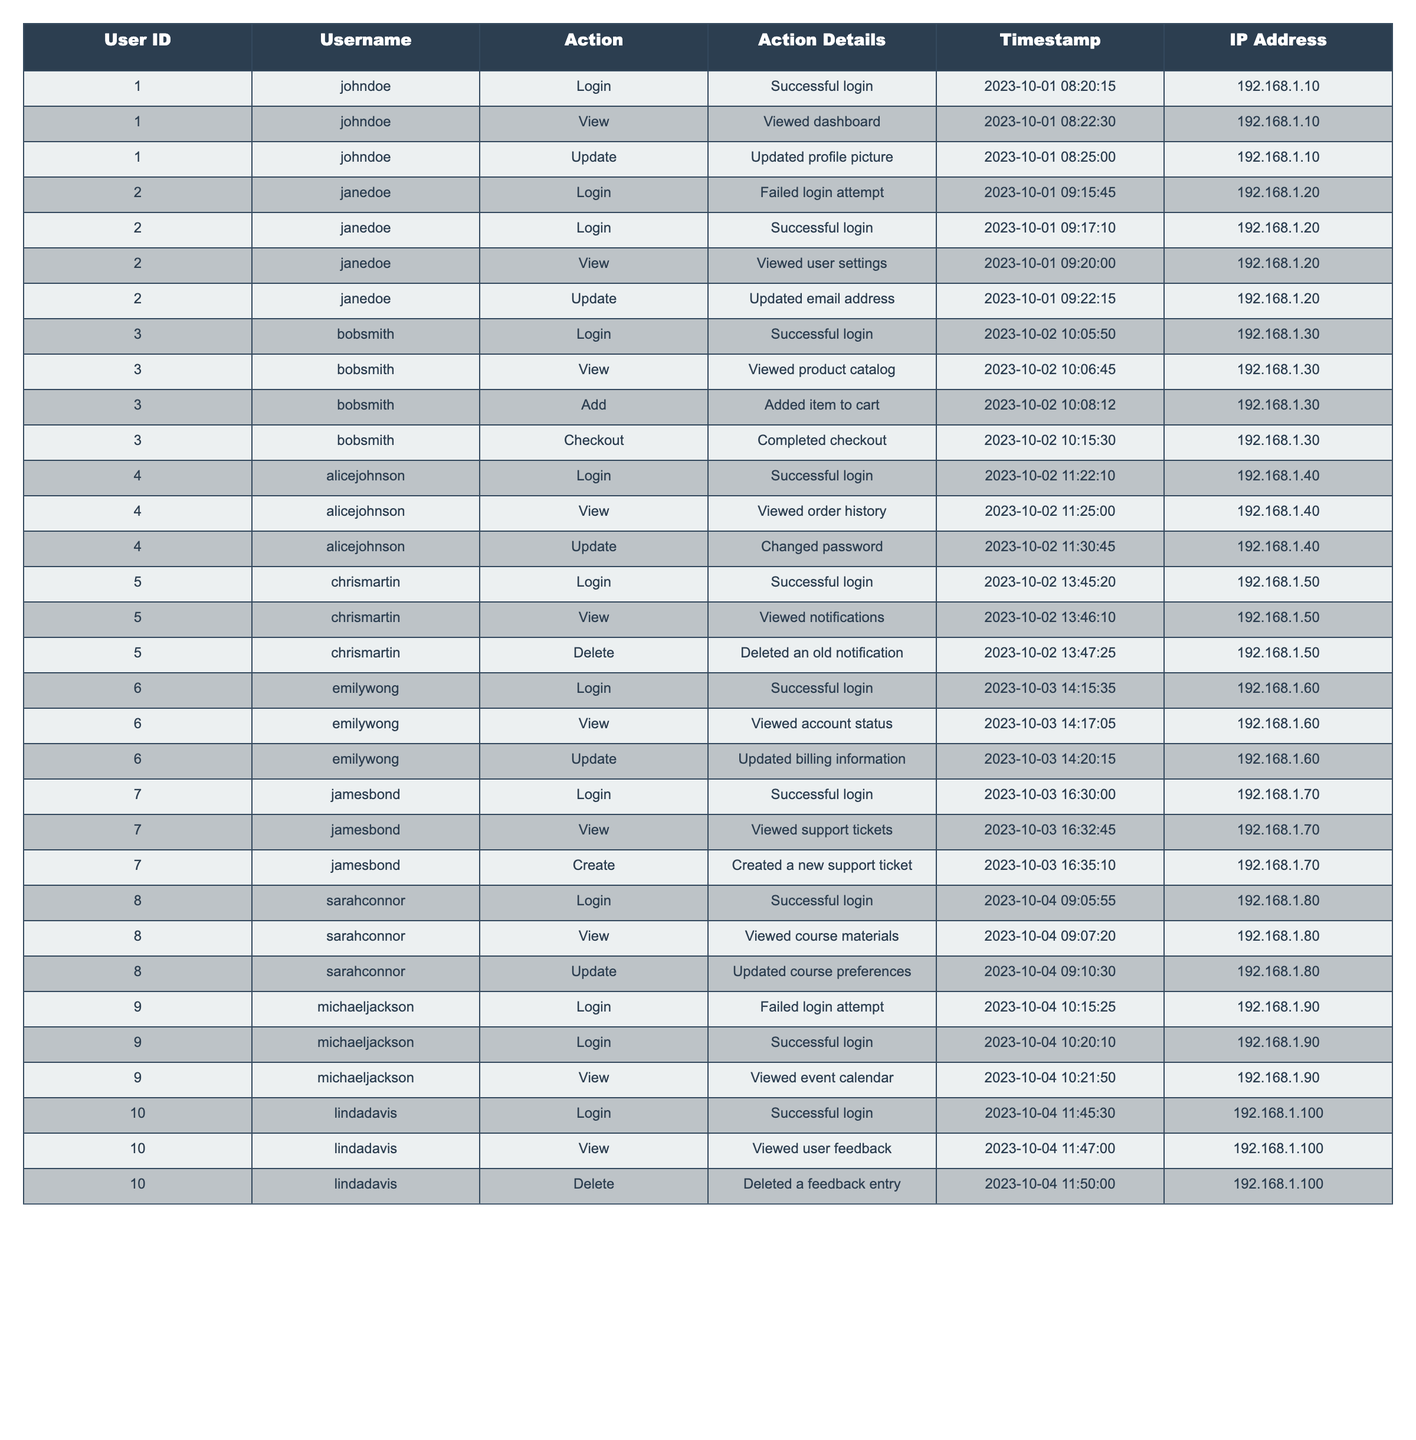What is the most recent action performed by user 'janedoe'? The table lists actions performed by each user along with timestamps. For 'janedoe', the most recent action is 'Updated email address' which occurred on '2023-10-01 09:22:15'.
Answer: Updated email address How many users have successfully logged in more than once? We can look through the logs for successful login actions. Users 'johndoe', 'janedoe', and 'michaeljackson' have logged in more than once, totaling three users.
Answer: 3 Did 'bobsmith' perform any add actions on the logged date? Looking at 'bobsmith's actions, he performed an 'Add' action on '2023-10-02 10:08:12'. Thus, the answer is yes.
Answer: Yes What was the timestamp for 'lindadavis' deleting a feedback entry? The entry for 'lindadavis' shows that she deleted a feedback entry at '2023-10-04 11:50:00'.
Answer: 2023-10-04 11:50:00 How many total actions did 'emilywong' perform? Counting all actions performed by 'emilywong', we find she completed three actions: 'Login', 'View', and 'Update', totaling three actions.
Answer: 3 Who is the first user to log in on October 3rd? Reviewing the timestamps on October 3rd, 'emilywong' is the first user to log in at '2023-10-03 14:15:35'.
Answer: emilywong What percentage of login attempts were successful for user 'michaeljackson'? Analyzing 'michaeljackson', he had one failed login and one successful login. This makes a total of two attempts, with one successful attempt. Therefore the percentage is (1/2)*100 = 50%.
Answer: 50% Which user's last recorded action was 'Changed password'? The last action for user 'alicejohnson' was 'Changed password' on '2023-10-02 11:30:45'. Thus 'alicejohnson' is the user.
Answer: alicejohnson How many unique actions did user 'jamesbond' perform? 'jamesbond' performed three unique actions: 'Login', 'View', and 'Create'. Therefore he has three unique actions.
Answer: 3 Is there a user who attempted to log in unsuccessfully? Yes, both 'janedoe' and 'michaeljackson' had failed login attempts, confirming that there are users with unsuccessful login attempts.
Answer: Yes Which action is most commonly performed based on the logs? Reviewing the actions across all users, 'Login' is the most common action as it appears 10 times, indicating that it is the most commonly performed action.
Answer: Login 